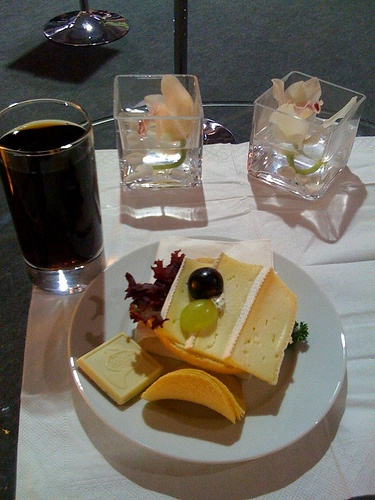Describe the objects in this image and their specific colors. I can see dining table in black, darkgray, and gray tones, cake in black, tan, olive, and maroon tones, cup in black, gray, and maroon tones, vase in black, darkgray, and gray tones, and cup in black, tan, gray, and darkgray tones in this image. 